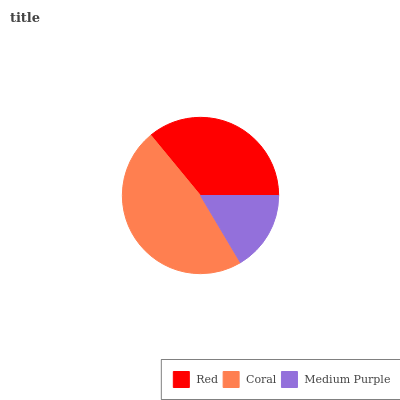Is Medium Purple the minimum?
Answer yes or no. Yes. Is Coral the maximum?
Answer yes or no. Yes. Is Coral the minimum?
Answer yes or no. No. Is Medium Purple the maximum?
Answer yes or no. No. Is Coral greater than Medium Purple?
Answer yes or no. Yes. Is Medium Purple less than Coral?
Answer yes or no. Yes. Is Medium Purple greater than Coral?
Answer yes or no. No. Is Coral less than Medium Purple?
Answer yes or no. No. Is Red the high median?
Answer yes or no. Yes. Is Red the low median?
Answer yes or no. Yes. Is Medium Purple the high median?
Answer yes or no. No. Is Medium Purple the low median?
Answer yes or no. No. 